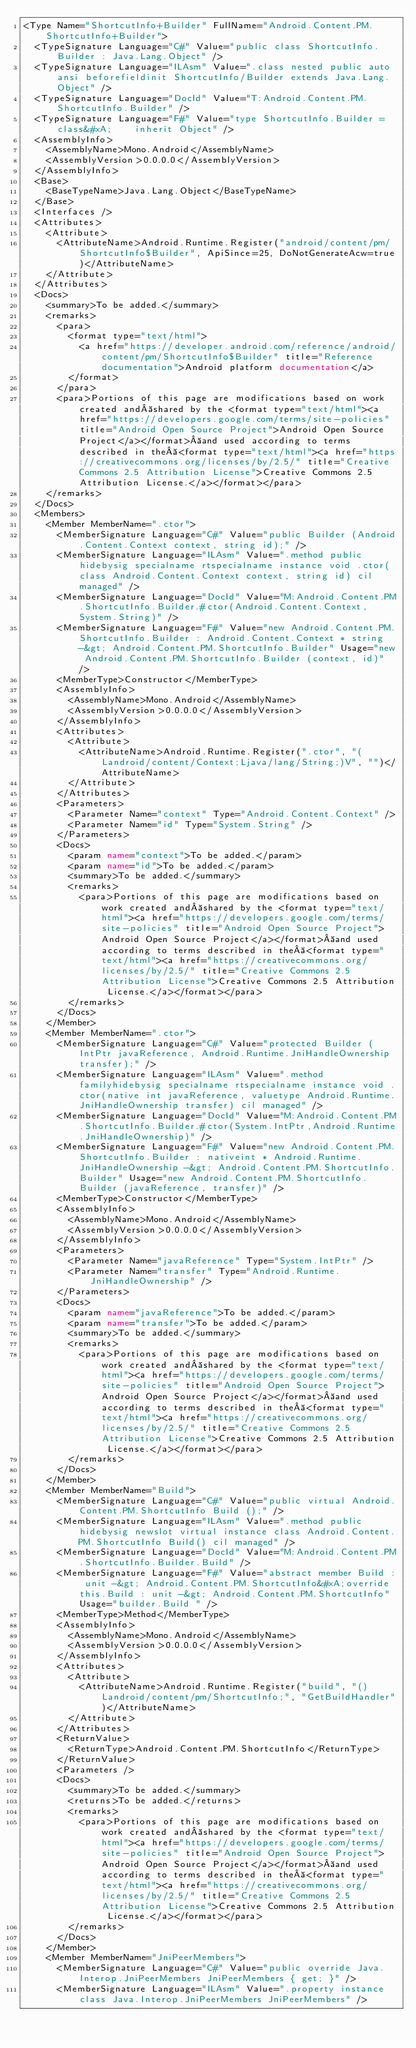Convert code to text. <code><loc_0><loc_0><loc_500><loc_500><_XML_><Type Name="ShortcutInfo+Builder" FullName="Android.Content.PM.ShortcutInfo+Builder">
  <TypeSignature Language="C#" Value="public class ShortcutInfo.Builder : Java.Lang.Object" />
  <TypeSignature Language="ILAsm" Value=".class nested public auto ansi beforefieldinit ShortcutInfo/Builder extends Java.Lang.Object" />
  <TypeSignature Language="DocId" Value="T:Android.Content.PM.ShortcutInfo.Builder" />
  <TypeSignature Language="F#" Value="type ShortcutInfo.Builder = class&#xA;    inherit Object" />
  <AssemblyInfo>
    <AssemblyName>Mono.Android</AssemblyName>
    <AssemblyVersion>0.0.0.0</AssemblyVersion>
  </AssemblyInfo>
  <Base>
    <BaseTypeName>Java.Lang.Object</BaseTypeName>
  </Base>
  <Interfaces />
  <Attributes>
    <Attribute>
      <AttributeName>Android.Runtime.Register("android/content/pm/ShortcutInfo$Builder", ApiSince=25, DoNotGenerateAcw=true)</AttributeName>
    </Attribute>
  </Attributes>
  <Docs>
    <summary>To be added.</summary>
    <remarks>
      <para>
        <format type="text/html">
          <a href="https://developer.android.com/reference/android/content/pm/ShortcutInfo$Builder" title="Reference documentation">Android platform documentation</a>
        </format>
      </para>
      <para>Portions of this page are modifications based on work created and shared by the <format type="text/html"><a href="https://developers.google.com/terms/site-policies" title="Android Open Source Project">Android Open Source Project</a></format> and used according to terms described in the <format type="text/html"><a href="https://creativecommons.org/licenses/by/2.5/" title="Creative Commons 2.5 Attribution License">Creative Commons 2.5 Attribution License.</a></format></para>
    </remarks>
  </Docs>
  <Members>
    <Member MemberName=".ctor">
      <MemberSignature Language="C#" Value="public Builder (Android.Content.Context context, string id);" />
      <MemberSignature Language="ILAsm" Value=".method public hidebysig specialname rtspecialname instance void .ctor(class Android.Content.Context context, string id) cil managed" />
      <MemberSignature Language="DocId" Value="M:Android.Content.PM.ShortcutInfo.Builder.#ctor(Android.Content.Context,System.String)" />
      <MemberSignature Language="F#" Value="new Android.Content.PM.ShortcutInfo.Builder : Android.Content.Context * string -&gt; Android.Content.PM.ShortcutInfo.Builder" Usage="new Android.Content.PM.ShortcutInfo.Builder (context, id)" />
      <MemberType>Constructor</MemberType>
      <AssemblyInfo>
        <AssemblyName>Mono.Android</AssemblyName>
        <AssemblyVersion>0.0.0.0</AssemblyVersion>
      </AssemblyInfo>
      <Attributes>
        <Attribute>
          <AttributeName>Android.Runtime.Register(".ctor", "(Landroid/content/Context;Ljava/lang/String;)V", "")</AttributeName>
        </Attribute>
      </Attributes>
      <Parameters>
        <Parameter Name="context" Type="Android.Content.Context" />
        <Parameter Name="id" Type="System.String" />
      </Parameters>
      <Docs>
        <param name="context">To be added.</param>
        <param name="id">To be added.</param>
        <summary>To be added.</summary>
        <remarks>
          <para>Portions of this page are modifications based on work created and shared by the <format type="text/html"><a href="https://developers.google.com/terms/site-policies" title="Android Open Source Project">Android Open Source Project</a></format> and used according to terms described in the <format type="text/html"><a href="https://creativecommons.org/licenses/by/2.5/" title="Creative Commons 2.5 Attribution License">Creative Commons 2.5 Attribution License.</a></format></para>
        </remarks>
      </Docs>
    </Member>
    <Member MemberName=".ctor">
      <MemberSignature Language="C#" Value="protected Builder (IntPtr javaReference, Android.Runtime.JniHandleOwnership transfer);" />
      <MemberSignature Language="ILAsm" Value=".method familyhidebysig specialname rtspecialname instance void .ctor(native int javaReference, valuetype Android.Runtime.JniHandleOwnership transfer) cil managed" />
      <MemberSignature Language="DocId" Value="M:Android.Content.PM.ShortcutInfo.Builder.#ctor(System.IntPtr,Android.Runtime.JniHandleOwnership)" />
      <MemberSignature Language="F#" Value="new Android.Content.PM.ShortcutInfo.Builder : nativeint * Android.Runtime.JniHandleOwnership -&gt; Android.Content.PM.ShortcutInfo.Builder" Usage="new Android.Content.PM.ShortcutInfo.Builder (javaReference, transfer)" />
      <MemberType>Constructor</MemberType>
      <AssemblyInfo>
        <AssemblyName>Mono.Android</AssemblyName>
        <AssemblyVersion>0.0.0.0</AssemblyVersion>
      </AssemblyInfo>
      <Parameters>
        <Parameter Name="javaReference" Type="System.IntPtr" />
        <Parameter Name="transfer" Type="Android.Runtime.JniHandleOwnership" />
      </Parameters>
      <Docs>
        <param name="javaReference">To be added.</param>
        <param name="transfer">To be added.</param>
        <summary>To be added.</summary>
        <remarks>
          <para>Portions of this page are modifications based on work created and shared by the <format type="text/html"><a href="https://developers.google.com/terms/site-policies" title="Android Open Source Project">Android Open Source Project</a></format> and used according to terms described in the <format type="text/html"><a href="https://creativecommons.org/licenses/by/2.5/" title="Creative Commons 2.5 Attribution License">Creative Commons 2.5 Attribution License.</a></format></para>
        </remarks>
      </Docs>
    </Member>
    <Member MemberName="Build">
      <MemberSignature Language="C#" Value="public virtual Android.Content.PM.ShortcutInfo Build ();" />
      <MemberSignature Language="ILAsm" Value=".method public hidebysig newslot virtual instance class Android.Content.PM.ShortcutInfo Build() cil managed" />
      <MemberSignature Language="DocId" Value="M:Android.Content.PM.ShortcutInfo.Builder.Build" />
      <MemberSignature Language="F#" Value="abstract member Build : unit -&gt; Android.Content.PM.ShortcutInfo&#xA;override this.Build : unit -&gt; Android.Content.PM.ShortcutInfo" Usage="builder.Build " />
      <MemberType>Method</MemberType>
      <AssemblyInfo>
        <AssemblyName>Mono.Android</AssemblyName>
        <AssemblyVersion>0.0.0.0</AssemblyVersion>
      </AssemblyInfo>
      <Attributes>
        <Attribute>
          <AttributeName>Android.Runtime.Register("build", "()Landroid/content/pm/ShortcutInfo;", "GetBuildHandler")</AttributeName>
        </Attribute>
      </Attributes>
      <ReturnValue>
        <ReturnType>Android.Content.PM.ShortcutInfo</ReturnType>
      </ReturnValue>
      <Parameters />
      <Docs>
        <summary>To be added.</summary>
        <returns>To be added.</returns>
        <remarks>
          <para>Portions of this page are modifications based on work created and shared by the <format type="text/html"><a href="https://developers.google.com/terms/site-policies" title="Android Open Source Project">Android Open Source Project</a></format> and used according to terms described in the <format type="text/html"><a href="https://creativecommons.org/licenses/by/2.5/" title="Creative Commons 2.5 Attribution License">Creative Commons 2.5 Attribution License.</a></format></para>
        </remarks>
      </Docs>
    </Member>
    <Member MemberName="JniPeerMembers">
      <MemberSignature Language="C#" Value="public override Java.Interop.JniPeerMembers JniPeerMembers { get; }" />
      <MemberSignature Language="ILAsm" Value=".property instance class Java.Interop.JniPeerMembers JniPeerMembers" /></code> 